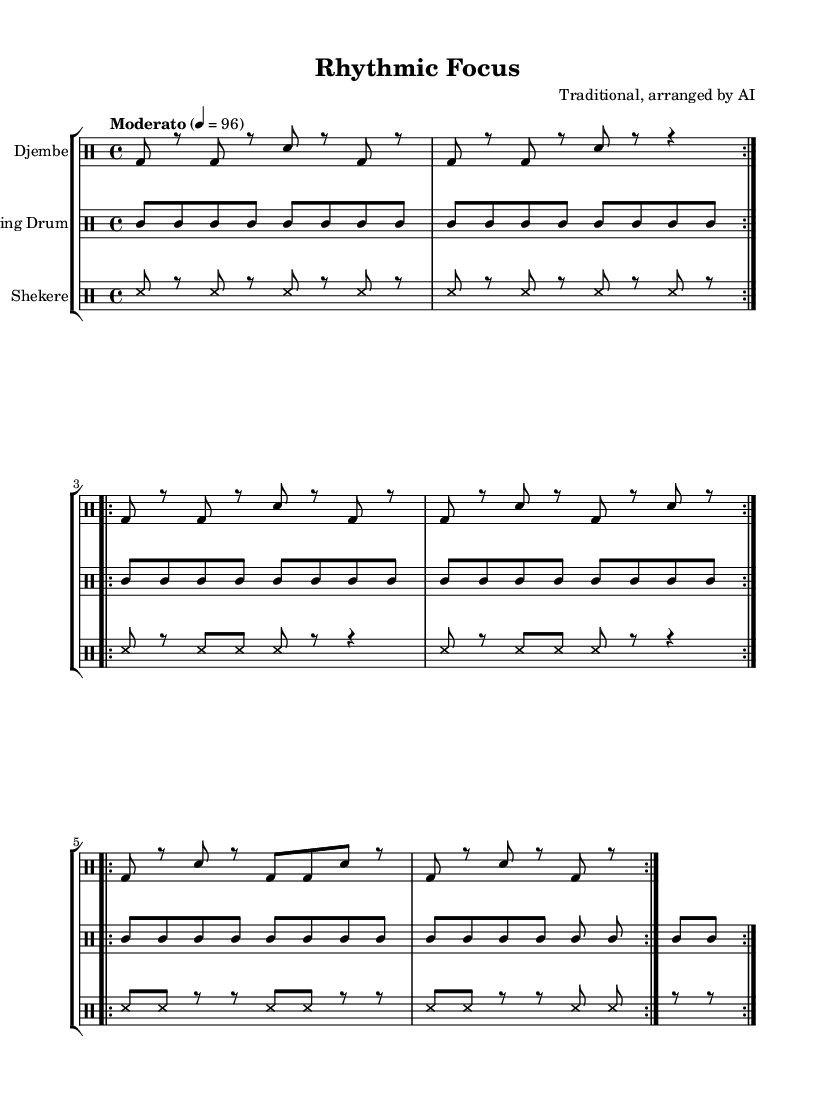What is the time signature of this music? The time signature appears at the beginning of the score and is indicated as 4/4, meaning there are four beats in each measure and the quarter note gets one beat.
Answer: 4/4 What is the tempo marking for this piece? The tempo marking is located at the beginning of the sheet music, indicated as "Moderato" with a metronome marking of 96 beats per minute.
Answer: Moderato, 96 How many measures are there in the djembe part? By counting the repetitions in the djembe rhythm, it shows that each section is repeated 2 times for a total of 6 sections, leading to 12 measures in the entire part.
Answer: 12 What type of drums are used in this arrangement? The instruments are listed at the start of each drum staff, indicating that the piece includes Djembe, Talking Drum, and Shekere as the primary percussion instruments.
Answer: Djembe, Talking Drum, Shekere How does the rhythmic structure of the shekere differ from the djembe? The shekere has a more consistent pattern of short strokes with frequent rest notes, while the djembe includes a variety of strokes and rests, creating a more complex rhythmic texture.
Answer: Consistent pattern vs. complex rhythm What is the notation style used for the rhythms in this piece? The rhythms are notated using traditional drum notation, which employs different shapes and symbols to represent the sounds produced by each percussion instrument.
Answer: Traditional drum notation 